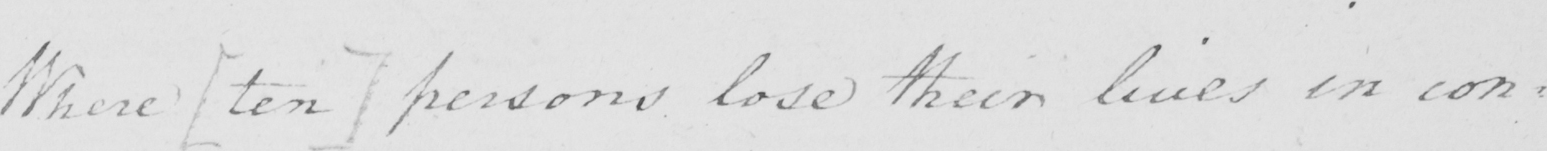What text is written in this handwritten line? Where  [ ten ]  persons lose their lives in con= 